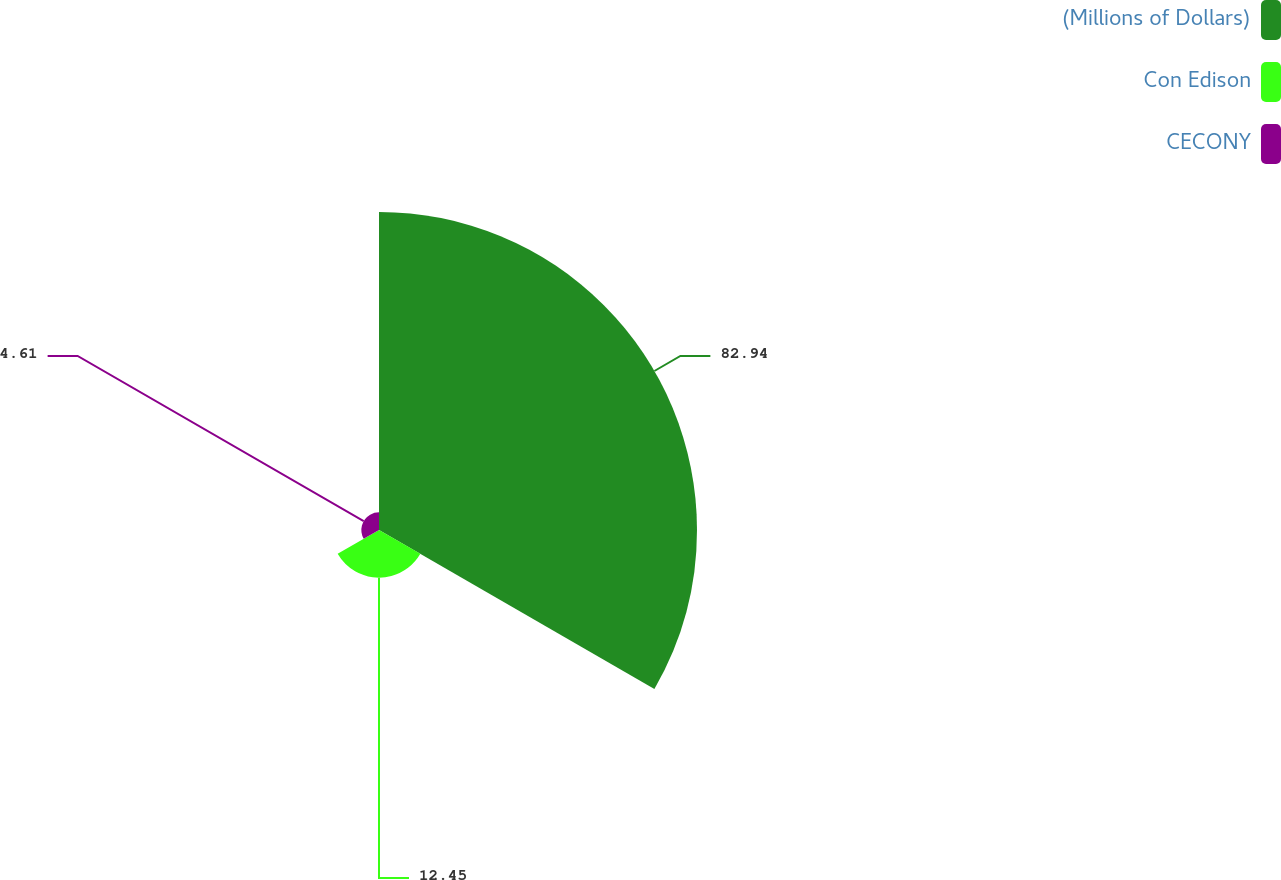<chart> <loc_0><loc_0><loc_500><loc_500><pie_chart><fcel>(Millions of Dollars)<fcel>Con Edison<fcel>CECONY<nl><fcel>82.94%<fcel>12.45%<fcel>4.61%<nl></chart> 